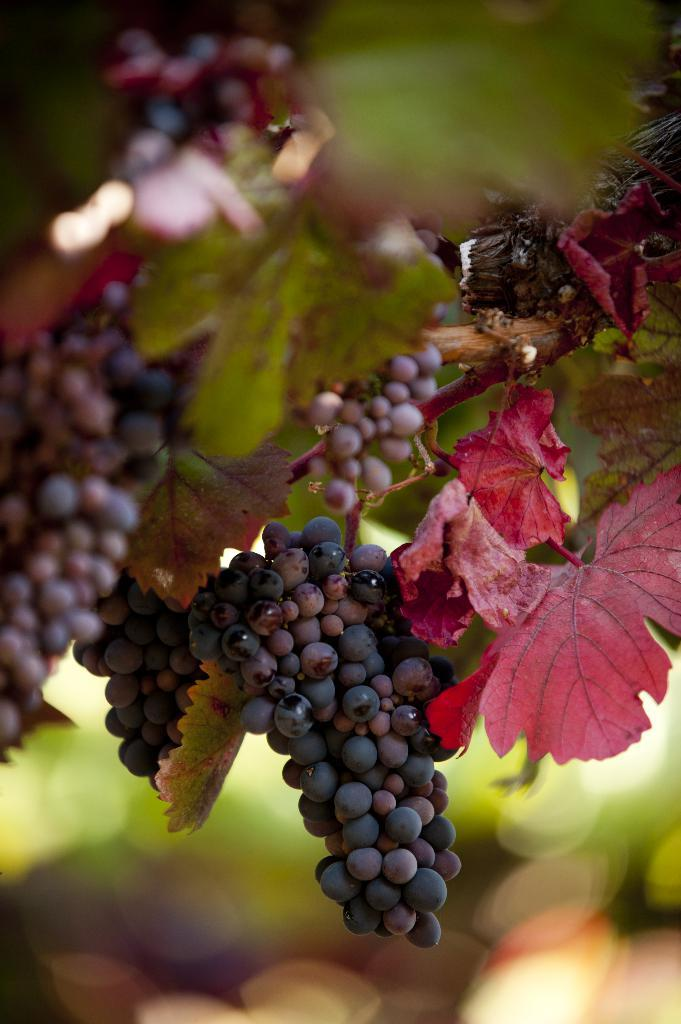What type of plant can be seen in the image? The image contains branches of grapes. What other elements can be seen alongside the grapes in the image? The image contains leaves. Can you describe the background of the image? The background of the image is blurred. What type of property can be seen in the background of the image? There is no property visible in the image; it only contains branches of grapes and leaves. What role does the moon play in the image? The moon is not present in the image; it only contains branches of grapes and leaves. 